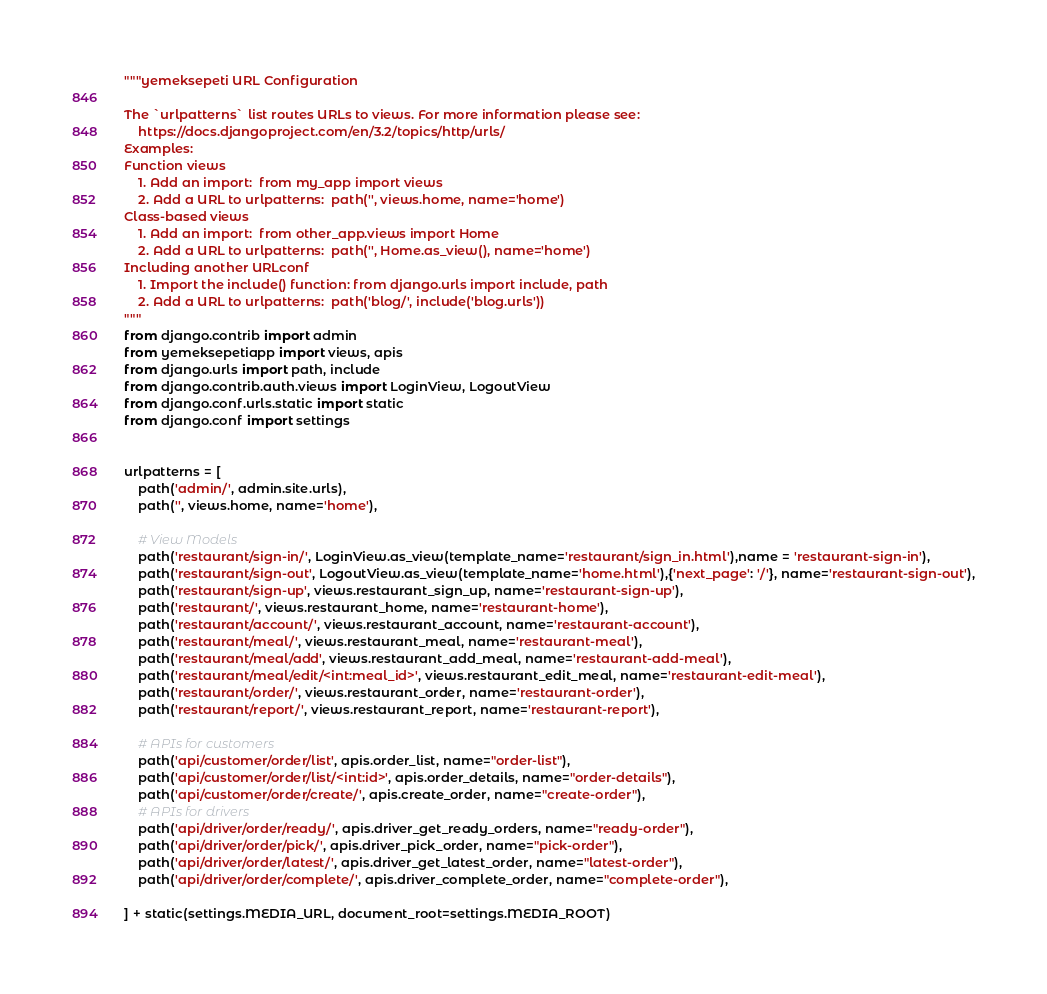<code> <loc_0><loc_0><loc_500><loc_500><_Python_>"""yemeksepeti URL Configuration

The `urlpatterns` list routes URLs to views. For more information please see:
    https://docs.djangoproject.com/en/3.2/topics/http/urls/
Examples:
Function views
    1. Add an import:  from my_app import views
    2. Add a URL to urlpatterns:  path('', views.home, name='home')
Class-based views
    1. Add an import:  from other_app.views import Home
    2. Add a URL to urlpatterns:  path('', Home.as_view(), name='home')
Including another URLconf
    1. Import the include() function: from django.urls import include, path
    2. Add a URL to urlpatterns:  path('blog/', include('blog.urls'))
"""
from django.contrib import admin
from yemeksepetiapp import views, apis
from django.urls import path, include
from django.contrib.auth.views import LoginView, LogoutView
from django.conf.urls.static import static
from django.conf import settings


urlpatterns = [
    path('admin/', admin.site.urls),
    path('', views.home, name='home'),

    # View Models
    path('restaurant/sign-in/', LoginView.as_view(template_name='restaurant/sign_in.html'),name = 'restaurant-sign-in'),
    path('restaurant/sign-out', LogoutView.as_view(template_name='home.html'),{'next_page': '/'}, name='restaurant-sign-out'),
    path('restaurant/sign-up', views.restaurant_sign_up, name='restaurant-sign-up'),
    path('restaurant/', views.restaurant_home, name='restaurant-home'),
    path('restaurant/account/', views.restaurant_account, name='restaurant-account'),
    path('restaurant/meal/', views.restaurant_meal, name='restaurant-meal'),
    path('restaurant/meal/add', views.restaurant_add_meal, name='restaurant-add-meal'),
    path('restaurant/meal/edit/<int:meal_id>', views.restaurant_edit_meal, name='restaurant-edit-meal'),
    path('restaurant/order/', views.restaurant_order, name='restaurant-order'),
    path('restaurant/report/', views.restaurant_report, name='restaurant-report'),

    # APIs for customers
    path('api/customer/order/list', apis.order_list, name="order-list"),
    path('api/customer/order/list/<int:id>', apis.order_details, name="order-details"),
    path('api/customer/order/create/', apis.create_order, name="create-order"),
    # APIs for drivers
    path('api/driver/order/ready/', apis.driver_get_ready_orders, name="ready-order"),
    path('api/driver/order/pick/', apis.driver_pick_order, name="pick-order"),
    path('api/driver/order/latest/', apis.driver_get_latest_order, name="latest-order"),
    path('api/driver/order/complete/', apis.driver_complete_order, name="complete-order"),

] + static(settings.MEDIA_URL, document_root=settings.MEDIA_ROOT)
</code> 